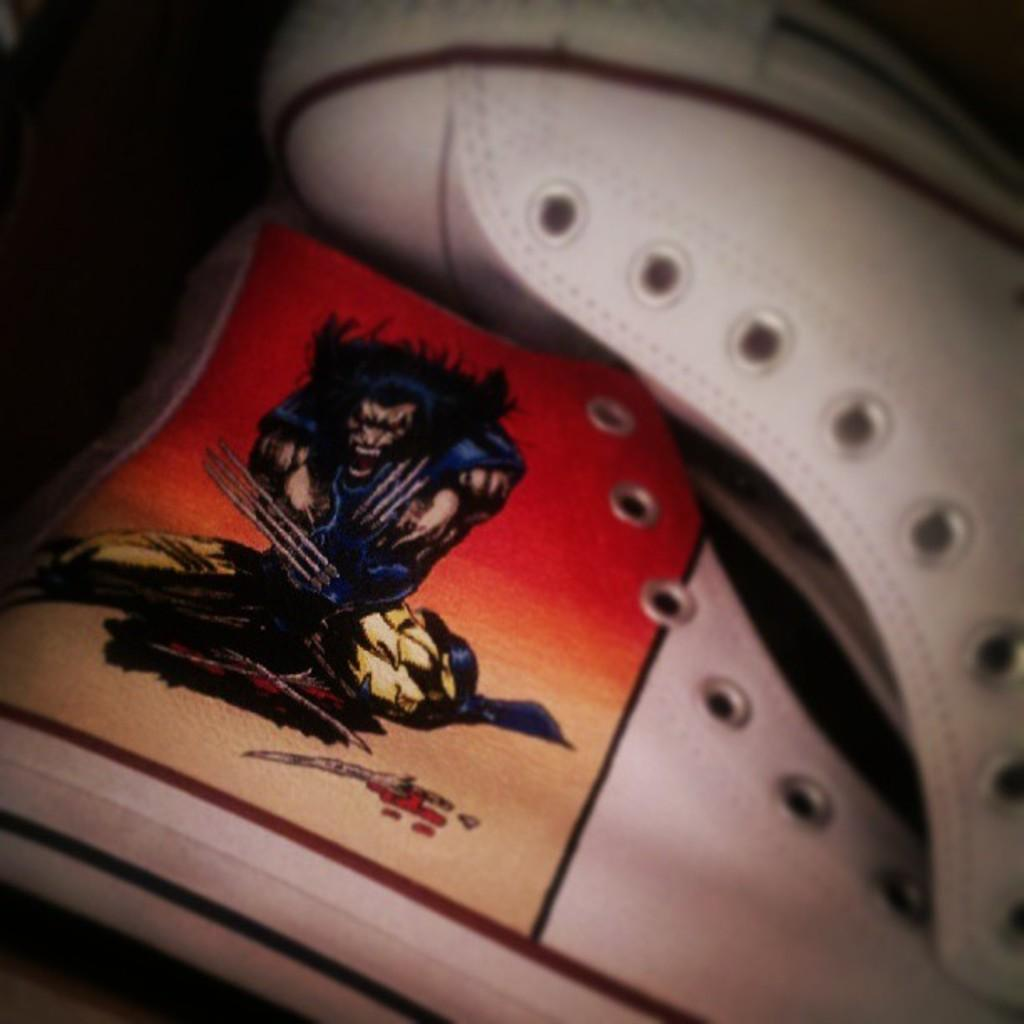What type of footwear is visible in the image? There is a pair of white color shoes in the image. Where are the shoes located in the image? The shoes are in the front of the image. What is the color of the background in the image? The background of the image is dark. How much money is being exchanged in the image? There is no exchange of money depicted in the image; it features a pair of white color shoes. What type of playground equipment can be seen in the image? There is no playground equipment present in the image. 